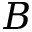Convert formula to latex. <formula><loc_0><loc_0><loc_500><loc_500>B</formula> 